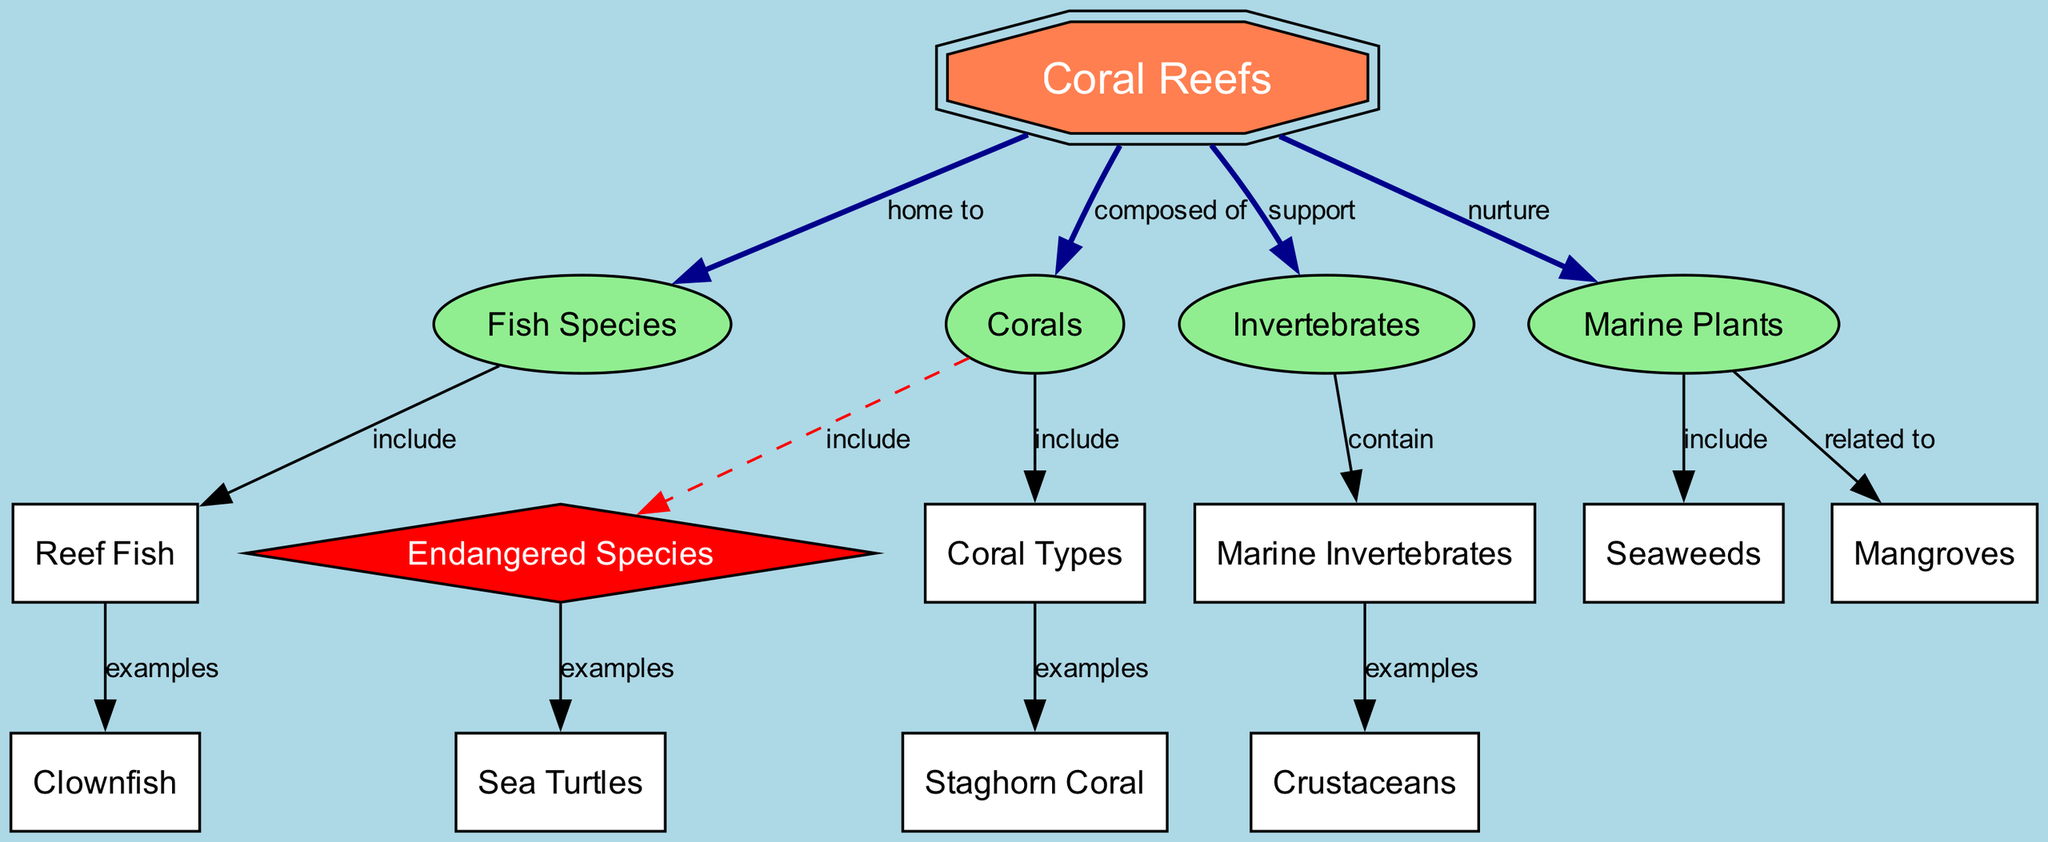What are coral reefs composed of? Coral reefs are composed of corals, as indicated by the edge labeled "composed of" connecting "coral reefs" to "corals."
Answer: corals How many types of endangered species are mentioned in the diagram? The diagram indicates that endangered species include examples such as sea turtles, hence the quantity of types is one as per the direct connection shown.
Answer: 1 What do marine plants nurture in coral reefs? The diagram shows that marine plants nurture coral reefs, represented by the edge labeled "nurture" connecting "marine plants" to "coral reefs."
Answer: coral reefs Which fish species includes clownfish? The edge indicating that fish species include reef fish specifies that clownfish is an example of reef fish reflected in the connections.
Answer: reef fish What are examples of coral types listed in the diagram? The diagram indicates that coral types include staghorn coral, which is explicitly shown as an example in the diagram.
Answer: staghorn coral Which plants are related to marine plants in the diagram? The connection labeled "related to" between marine plants and mangroves shows that mangroves are associated with marine plants.
Answer: mangroves What category of marine life do crustaceans represent? The edge states that marine invertebrates contain examples of crustaceans, directly linking crustaceans to the invertebrate category.
Answer: marine invertebrates What is included in the fish species? The diagram indicates that fish species include reef fish, directing focus to this subclass of fish.
Answer: reef fish 